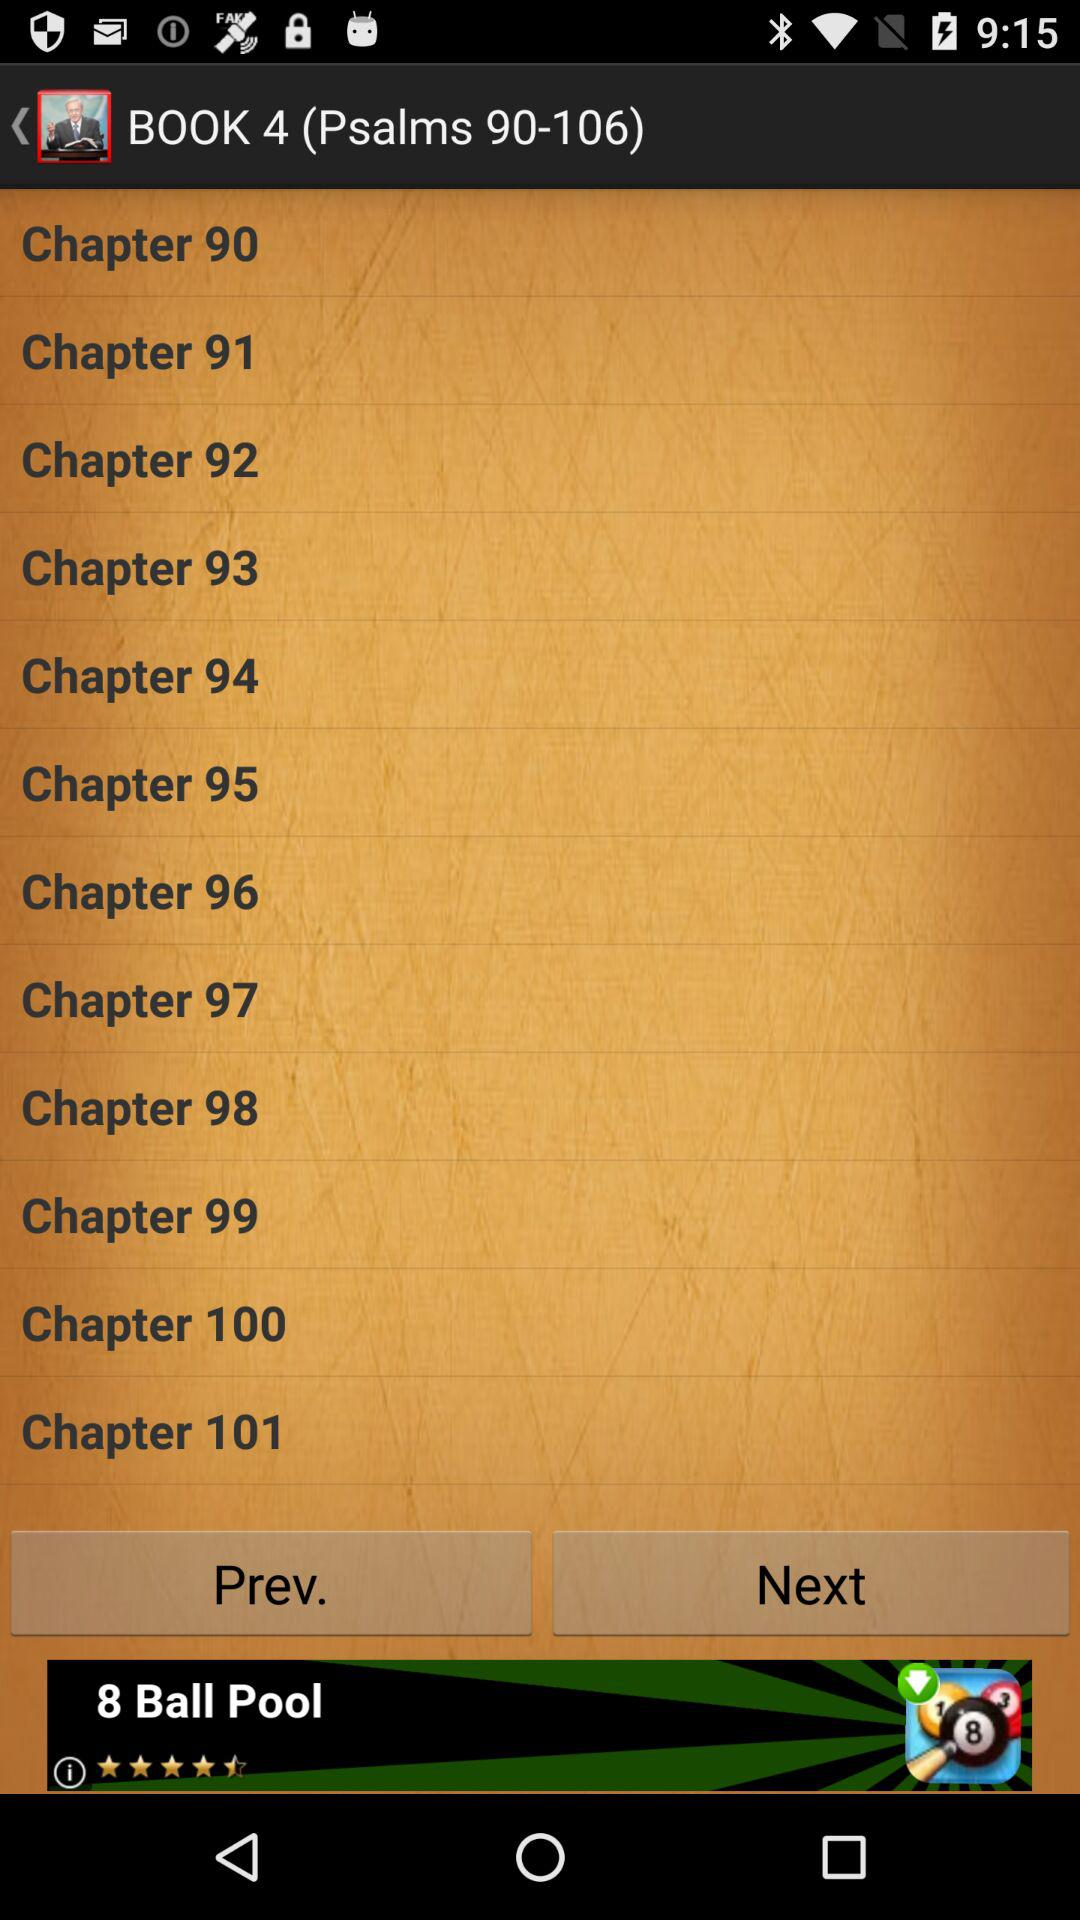Which book contains "Psalms 42-72"? "Psalms 42-72" are in book 3. 